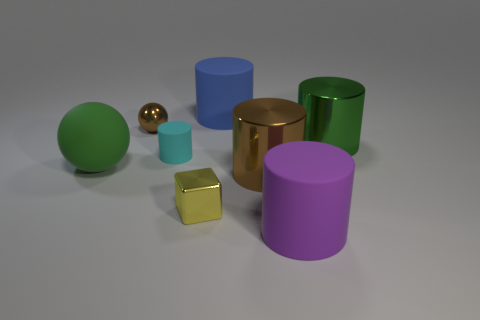Do the cyan matte thing behind the green ball and the green object that is on the right side of the cyan matte cylinder have the same shape?
Your answer should be compact. Yes. What material is the green thing that is the same size as the matte ball?
Your answer should be very brief. Metal. Are the green object on the right side of the small block and the object that is in front of the tiny shiny cube made of the same material?
Your response must be concise. No. There is a brown metallic object that is the same size as the cyan object; what shape is it?
Offer a very short reply. Sphere. What number of other objects are the same color as the rubber ball?
Your response must be concise. 1. There is a big thing that is left of the tiny cube; what is its color?
Provide a succinct answer. Green. How many other things are the same material as the large brown thing?
Your answer should be compact. 3. Is the number of small cyan things that are behind the matte sphere greater than the number of metal objects that are left of the brown cylinder?
Your response must be concise. No. There is a big rubber ball; how many things are behind it?
Make the answer very short. 4. Do the small sphere and the big blue cylinder behind the big brown metallic thing have the same material?
Offer a very short reply. No. 